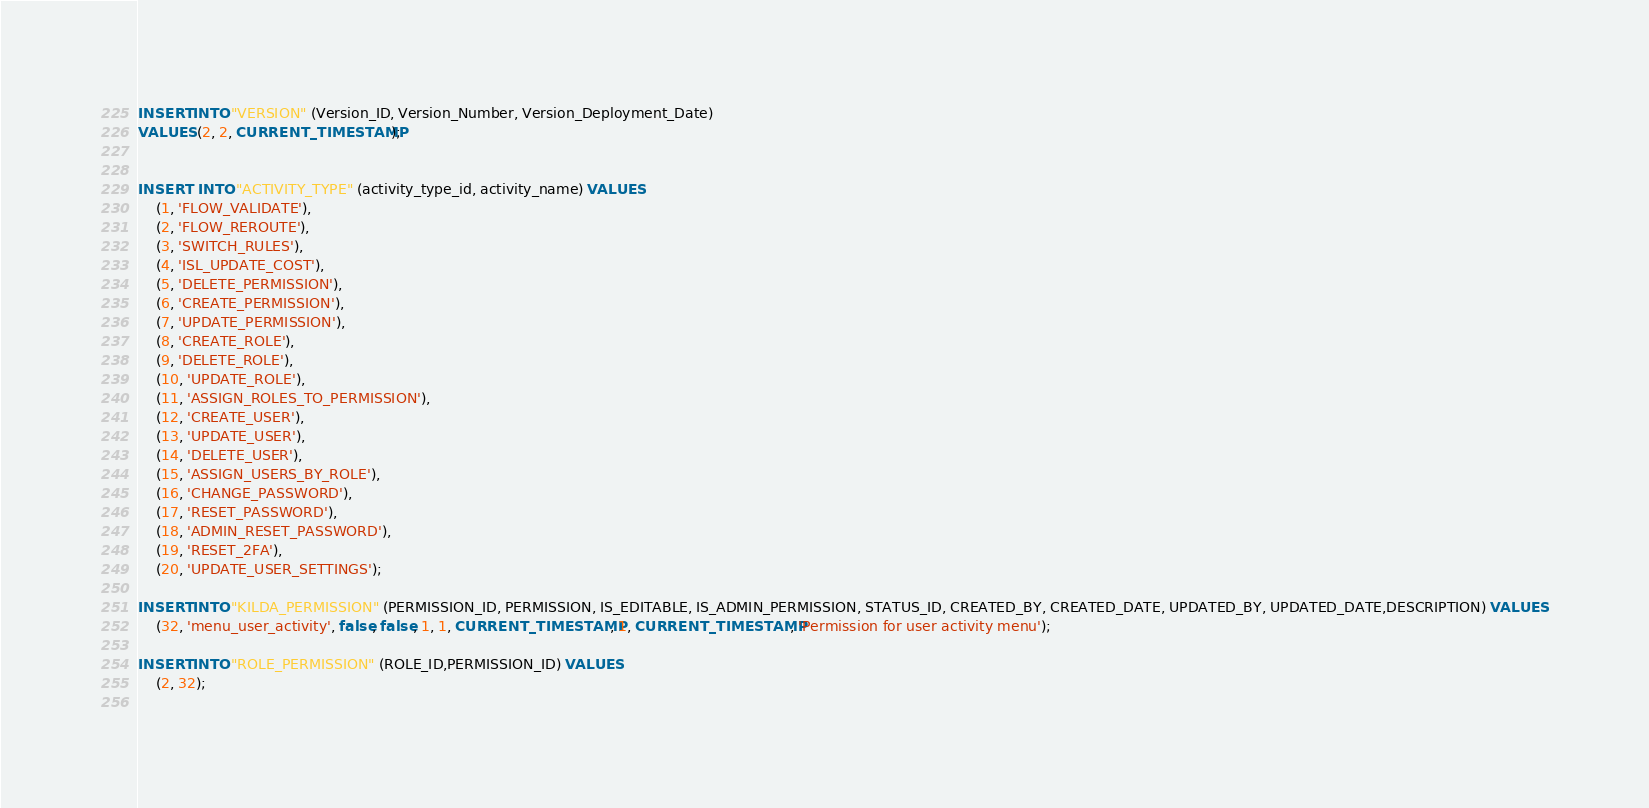Convert code to text. <code><loc_0><loc_0><loc_500><loc_500><_SQL_>INSERT INTO "VERSION" (Version_ID, Version_Number, Version_Deployment_Date)
VALUES (2, 2, CURRENT_TIMESTAMP);


INSERT  INTO "ACTIVITY_TYPE" (activity_type_id, activity_name) VALUES 
	(1, 'FLOW_VALIDATE'),
	(2, 'FLOW_REROUTE'),
	(3, 'SWITCH_RULES'),
	(4, 'ISL_UPDATE_COST'),
	(5, 'DELETE_PERMISSION'),
	(6, 'CREATE_PERMISSION'),
	(7, 'UPDATE_PERMISSION'),
	(8, 'CREATE_ROLE'),
	(9, 'DELETE_ROLE'),
	(10, 'UPDATE_ROLE'),
	(11, 'ASSIGN_ROLES_TO_PERMISSION'),
	(12, 'CREATE_USER'),
	(13, 'UPDATE_USER'),
	(14, 'DELETE_USER'),
	(15, 'ASSIGN_USERS_BY_ROLE'),
	(16, 'CHANGE_PASSWORD'),
	(17, 'RESET_PASSWORD'),
	(18, 'ADMIN_RESET_PASSWORD'),
	(19, 'RESET_2FA'),
	(20, 'UPDATE_USER_SETTINGS');
	
INSERT INTO "KILDA_PERMISSION" (PERMISSION_ID, PERMISSION, IS_EDITABLE, IS_ADMIN_PERMISSION, STATUS_ID, CREATED_BY, CREATED_DATE, UPDATED_BY, UPDATED_DATE,DESCRIPTION) VALUES 
	(32, 'menu_user_activity', false, false, 1, 1, CURRENT_TIMESTAMP, 1, CURRENT_TIMESTAMP, 'Permission for user activity menu');
	
INSERT INTO "ROLE_PERMISSION" (ROLE_ID,PERMISSION_ID) VALUES 
	(2, 32);
	</code> 